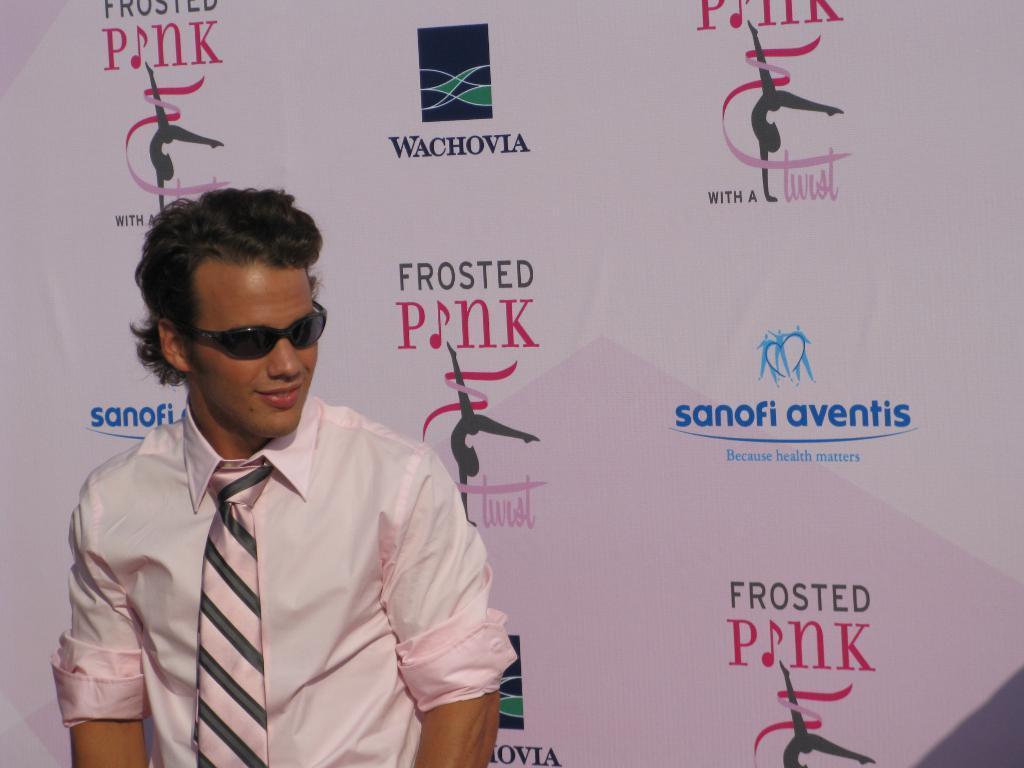Can you describe this image briefly? In this picture we can see a person wearing goggles, shirt and a tie is visible on the left side. We can see some text on a white surface. 